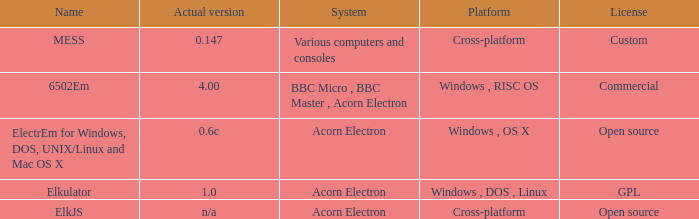What is the arrangement designated as elkjs? Acorn Electron. 